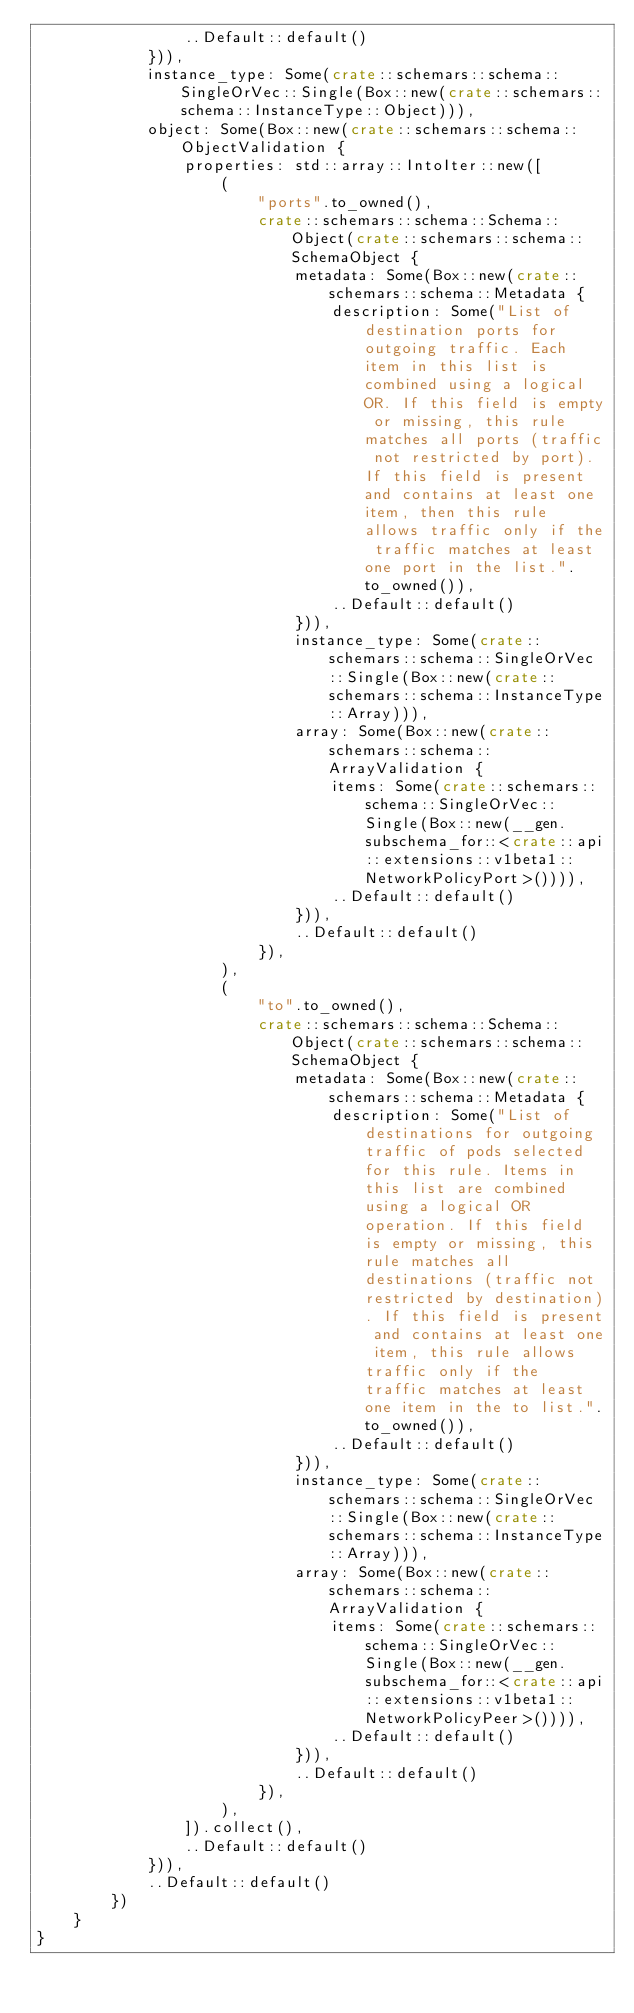Convert code to text. <code><loc_0><loc_0><loc_500><loc_500><_Rust_>                ..Default::default()
            })),
            instance_type: Some(crate::schemars::schema::SingleOrVec::Single(Box::new(crate::schemars::schema::InstanceType::Object))),
            object: Some(Box::new(crate::schemars::schema::ObjectValidation {
                properties: std::array::IntoIter::new([
                    (
                        "ports".to_owned(),
                        crate::schemars::schema::Schema::Object(crate::schemars::schema::SchemaObject {
                            metadata: Some(Box::new(crate::schemars::schema::Metadata {
                                description: Some("List of destination ports for outgoing traffic. Each item in this list is combined using a logical OR. If this field is empty or missing, this rule matches all ports (traffic not restricted by port). If this field is present and contains at least one item, then this rule allows traffic only if the traffic matches at least one port in the list.".to_owned()),
                                ..Default::default()
                            })),
                            instance_type: Some(crate::schemars::schema::SingleOrVec::Single(Box::new(crate::schemars::schema::InstanceType::Array))),
                            array: Some(Box::new(crate::schemars::schema::ArrayValidation {
                                items: Some(crate::schemars::schema::SingleOrVec::Single(Box::new(__gen.subschema_for::<crate::api::extensions::v1beta1::NetworkPolicyPort>()))),
                                ..Default::default()
                            })),
                            ..Default::default()
                        }),
                    ),
                    (
                        "to".to_owned(),
                        crate::schemars::schema::Schema::Object(crate::schemars::schema::SchemaObject {
                            metadata: Some(Box::new(crate::schemars::schema::Metadata {
                                description: Some("List of destinations for outgoing traffic of pods selected for this rule. Items in this list are combined using a logical OR operation. If this field is empty or missing, this rule matches all destinations (traffic not restricted by destination). If this field is present and contains at least one item, this rule allows traffic only if the traffic matches at least one item in the to list.".to_owned()),
                                ..Default::default()
                            })),
                            instance_type: Some(crate::schemars::schema::SingleOrVec::Single(Box::new(crate::schemars::schema::InstanceType::Array))),
                            array: Some(Box::new(crate::schemars::schema::ArrayValidation {
                                items: Some(crate::schemars::schema::SingleOrVec::Single(Box::new(__gen.subschema_for::<crate::api::extensions::v1beta1::NetworkPolicyPeer>()))),
                                ..Default::default()
                            })),
                            ..Default::default()
                        }),
                    ),
                ]).collect(),
                ..Default::default()
            })),
            ..Default::default()
        })
    }
}
</code> 